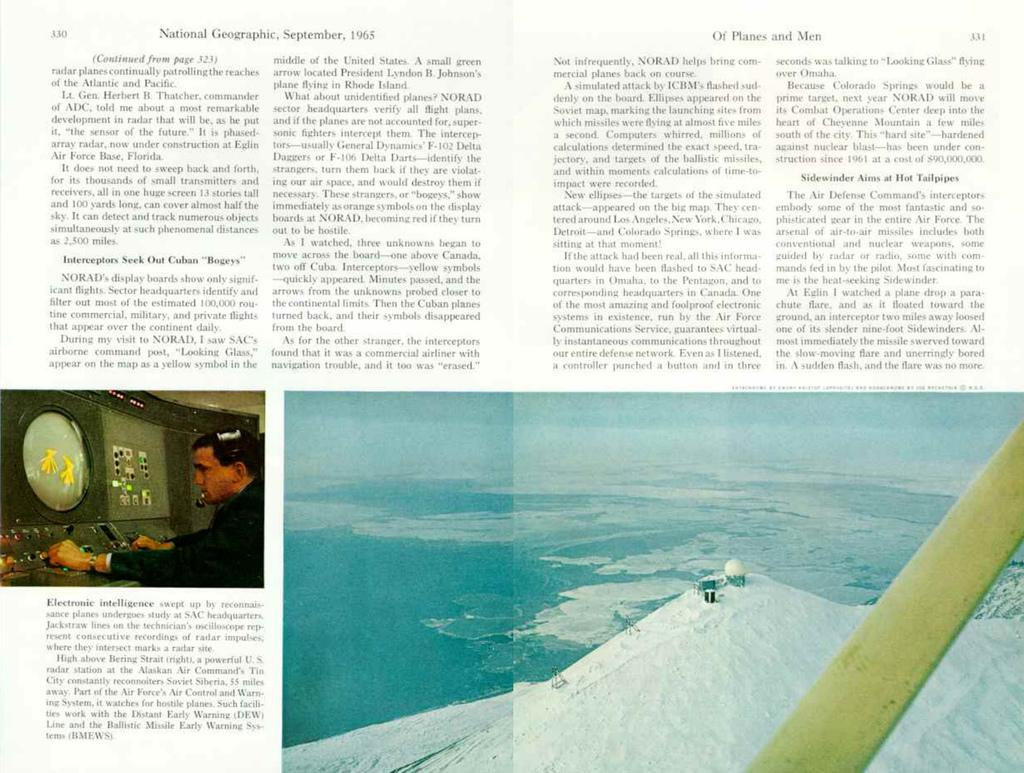What is present on the poster in the image? There is a poster in the image. What can be found on the poster besides images? The poster contains text. Can you describe the content of the poster? The poster contains both text and images. How does the doll contribute to the development of the poster in the image? There is no doll present in the image, and therefore it cannot contribute to the development of the poster. 